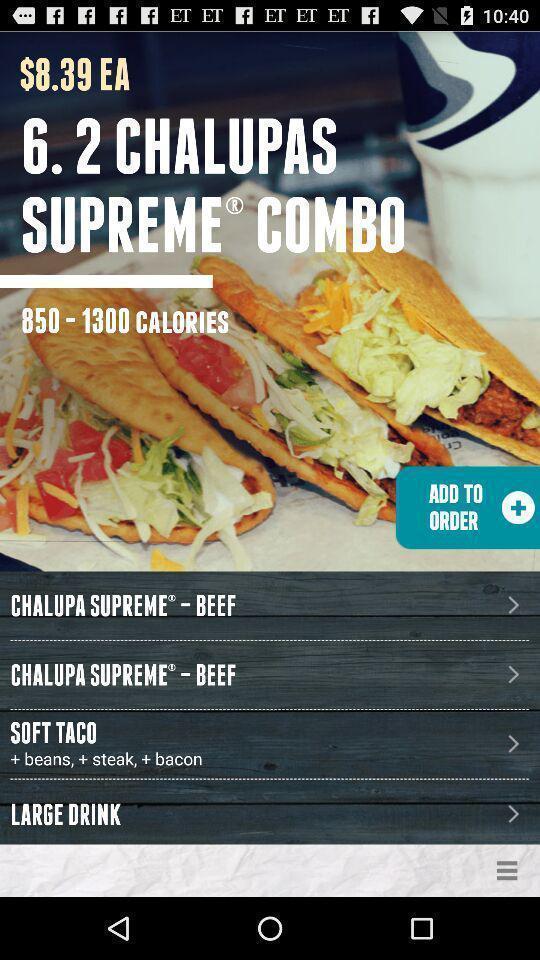What details can you identify in this image? Page displaying the food combo. 